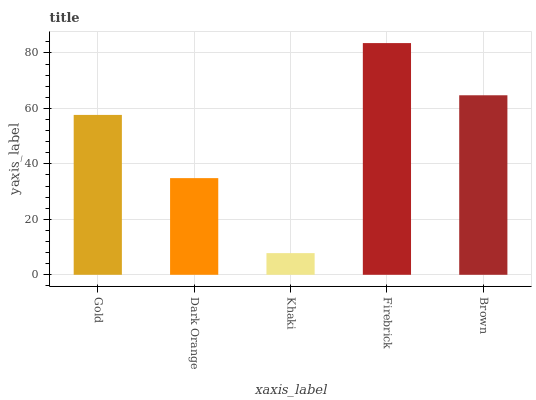Is Khaki the minimum?
Answer yes or no. Yes. Is Firebrick the maximum?
Answer yes or no. Yes. Is Dark Orange the minimum?
Answer yes or no. No. Is Dark Orange the maximum?
Answer yes or no. No. Is Gold greater than Dark Orange?
Answer yes or no. Yes. Is Dark Orange less than Gold?
Answer yes or no. Yes. Is Dark Orange greater than Gold?
Answer yes or no. No. Is Gold less than Dark Orange?
Answer yes or no. No. Is Gold the high median?
Answer yes or no. Yes. Is Gold the low median?
Answer yes or no. Yes. Is Firebrick the high median?
Answer yes or no. No. Is Dark Orange the low median?
Answer yes or no. No. 